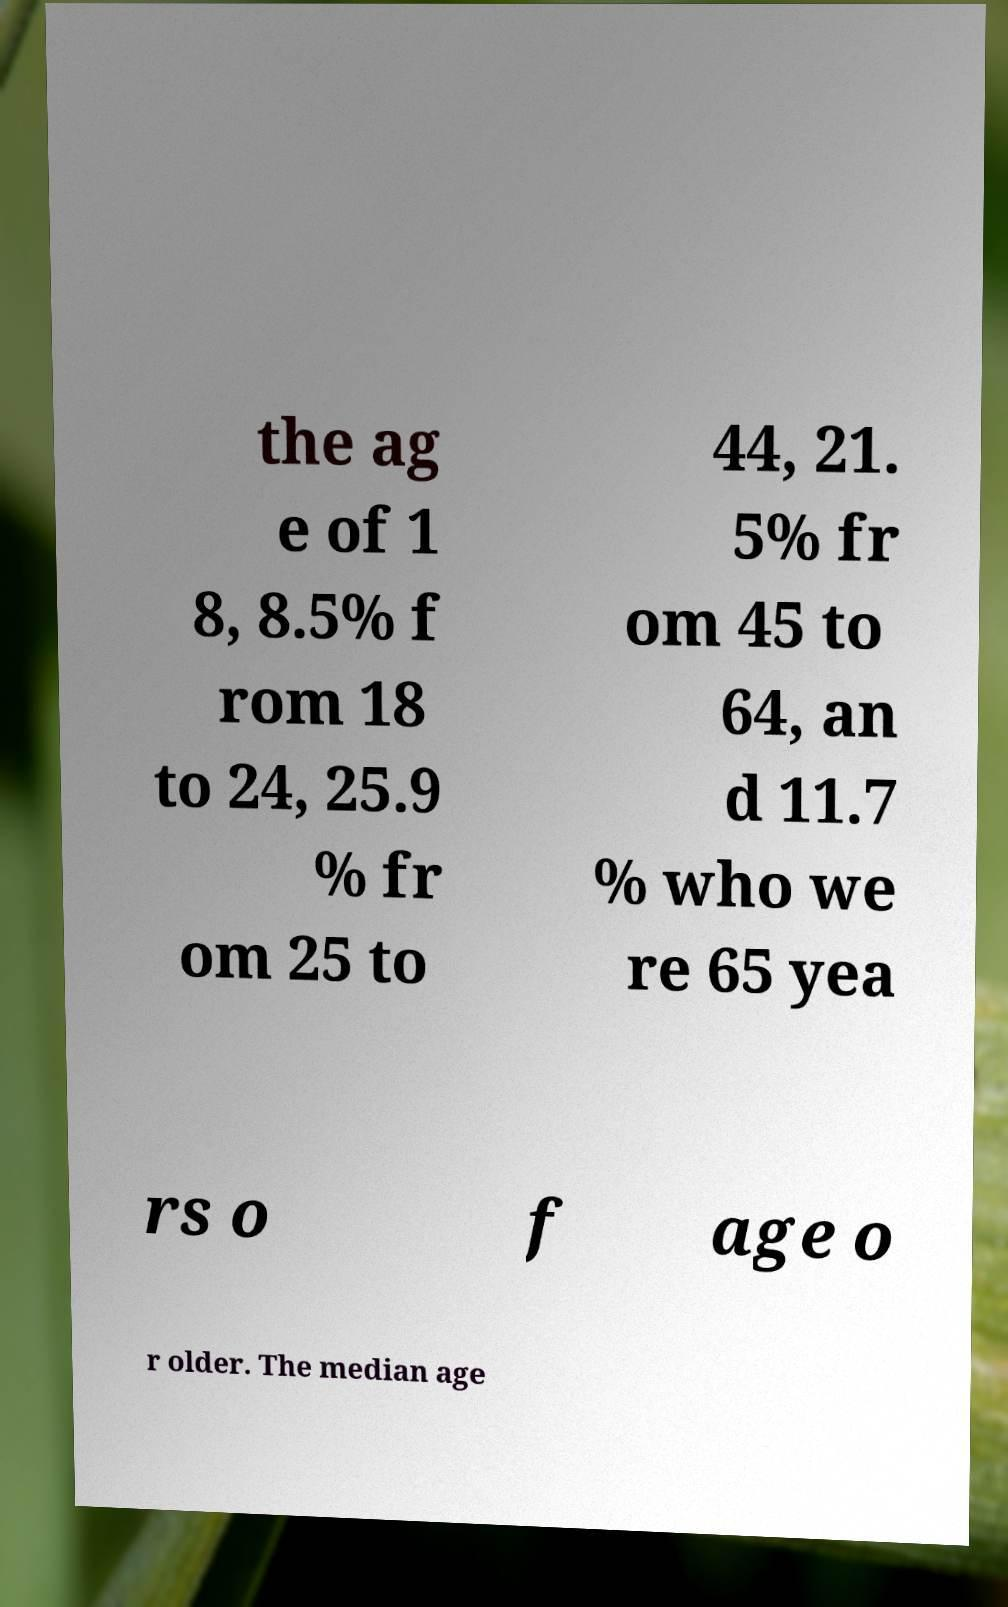There's text embedded in this image that I need extracted. Can you transcribe it verbatim? the ag e of 1 8, 8.5% f rom 18 to 24, 25.9 % fr om 25 to 44, 21. 5% fr om 45 to 64, an d 11.7 % who we re 65 yea rs o f age o r older. The median age 